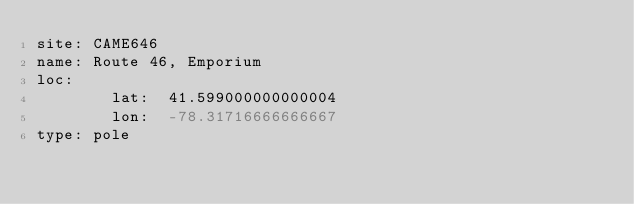Convert code to text. <code><loc_0><loc_0><loc_500><loc_500><_YAML_>site: CAME646
name: Route 46, Emporium
loc:
        lat:  41.599000000000004
        lon:  -78.31716666666667
type: pole
</code> 